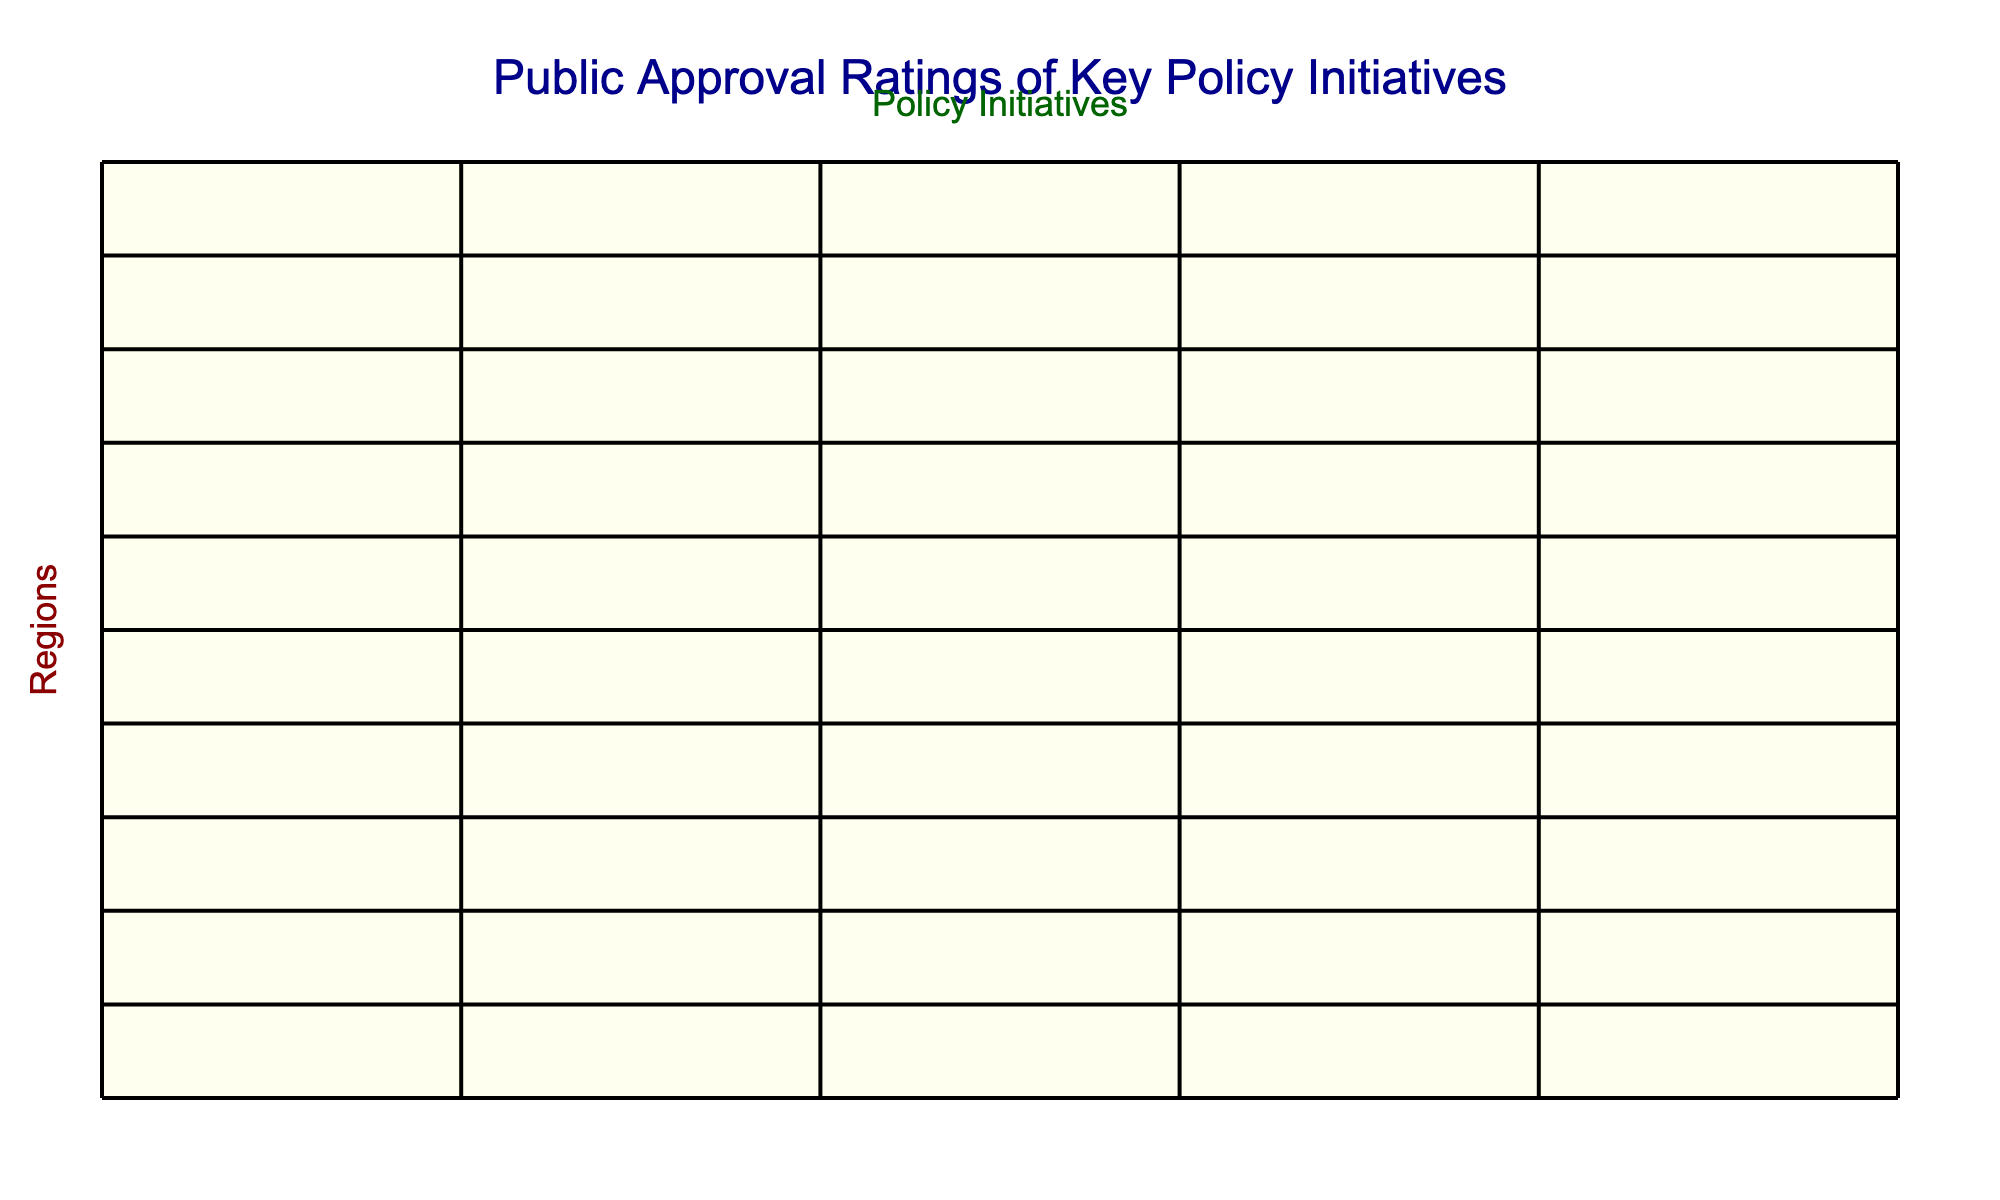What is the public approval rating for Climate Action in Urban Centers? From the table, the value under the Urban Centers row for Climate Action is 79%.
Answer: 79% Which region has the highest approval rating for Healthcare Reform? The highest approval rating for Healthcare Reform is in Urban Centers at 74%.
Answer: Urban Centers What is the difference between the approval ratings for Education Funding in the West and the South? The West has an approval rating of 68% for Education Funding, while the South has 61%. The difference is 68% - 61% = 7%.
Answer: 7% Is the approval rating for Immigration Reform in the Rust Belt higher than in the South? The Rust Belt's approval rating for Immigration Reform is 51%, while the South's is 47%. Therefore, the statement is true as 51% is greater than 47%.
Answer: Yes What is the average public approval rating for Tax Policy across all regions? First, we sum the Tax Policy ratings: (57 + 63 + 68 + 59 + 71 + 55 + 62 + 56 + 65 + 67) = 673. There are 10 regions, so the average approval rating is 673 / 10 = 67.3%.
Answer: 67.3% Which policy initiative has the lowest approval rating in Rural Areas? In Rural Areas, the lowest rating is for Climate Action at 45%.
Answer: Climate Action How do the approval ratings for Education Funding compare between Swing States and the Northeast? Swing States have a rating of 67% for Education Funding while the Northeast has 65%. The Swing States rating is higher by 2%.
Answer: 2% Is the public approval rating for Tax Policy in the Midwest more than 60%? The approval rating for Tax Policy in the Midwest is 63%, which is indeed more than 60%. Therefore, this statement is true.
Answer: Yes What is the highest combined approval rating for any two policy initiatives in the Coastal Regions? In the Coastal Regions, the approval ratings are: Healthcare Reform 70%, Climate Action 75%, Education Funding 66%, Tax Policy 56%, and Immigration Reform 63%. The highest combined rating is for Healthcare Reform and Climate Action: 70% + 75% = 145%.
Answer: 145% Which region has the lowest overall approval ratings across all policy initiatives? By analyzing the approval ratings, we find that Rural Areas have the lowest ratings with the highest being 59% and the lowest being 43%.
Answer: Rural Areas 